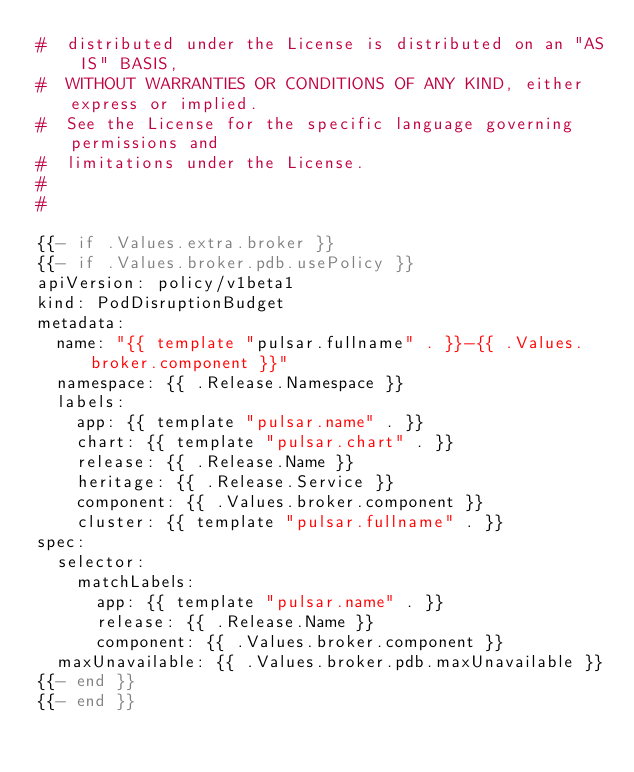<code> <loc_0><loc_0><loc_500><loc_500><_YAML_>#  distributed under the License is distributed on an "AS IS" BASIS,
#  WITHOUT WARRANTIES OR CONDITIONS OF ANY KIND, either express or implied.
#  See the License for the specific language governing permissions and
#  limitations under the License.
#  
# 

{{- if .Values.extra.broker }}
{{- if .Values.broker.pdb.usePolicy }}
apiVersion: policy/v1beta1
kind: PodDisruptionBudget
metadata:
  name: "{{ template "pulsar.fullname" . }}-{{ .Values.broker.component }}"
  namespace: {{ .Release.Namespace }}
  labels:
    app: {{ template "pulsar.name" . }}
    chart: {{ template "pulsar.chart" . }}
    release: {{ .Release.Name }}
    heritage: {{ .Release.Service }}
    component: {{ .Values.broker.component }}
    cluster: {{ template "pulsar.fullname" . }}
spec:
  selector:
    matchLabels:
      app: {{ template "pulsar.name" . }}
      release: {{ .Release.Name }}
      component: {{ .Values.broker.component }}
  maxUnavailable: {{ .Values.broker.pdb.maxUnavailable }}
{{- end }}
{{- end }}
</code> 